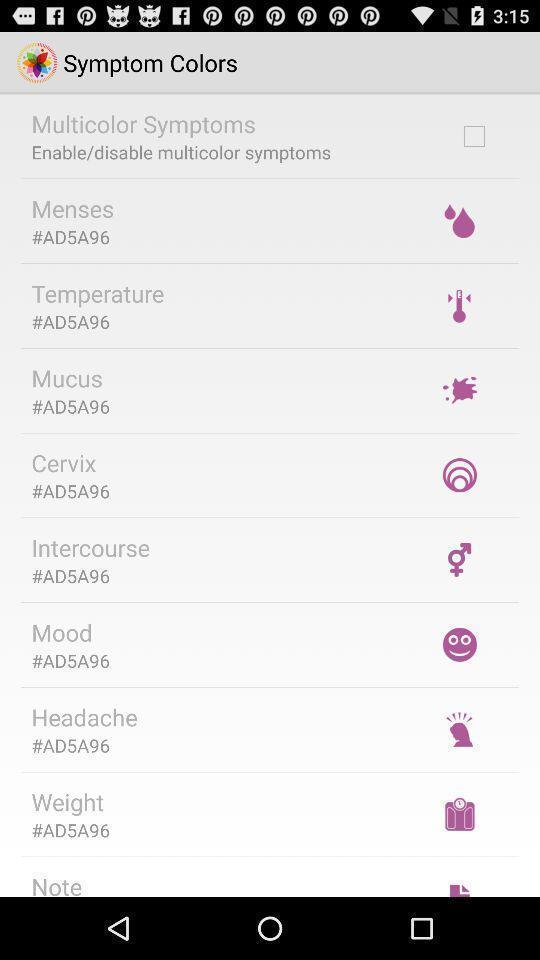Explain the elements present in this screenshot. Page displays different categories in the healthcare app. 